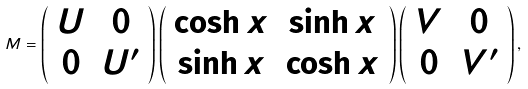<formula> <loc_0><loc_0><loc_500><loc_500>M = \left ( \begin{array} { c c } U & 0 \\ 0 & U ^ { \prime } \end{array} \right ) \left ( \begin{array} { c c } \cosh x & \sinh x \\ \sinh x & \cosh x \end{array} \right ) \left ( \begin{array} { c c } V & 0 \\ 0 & V ^ { \prime } \end{array} \right ) ,</formula> 